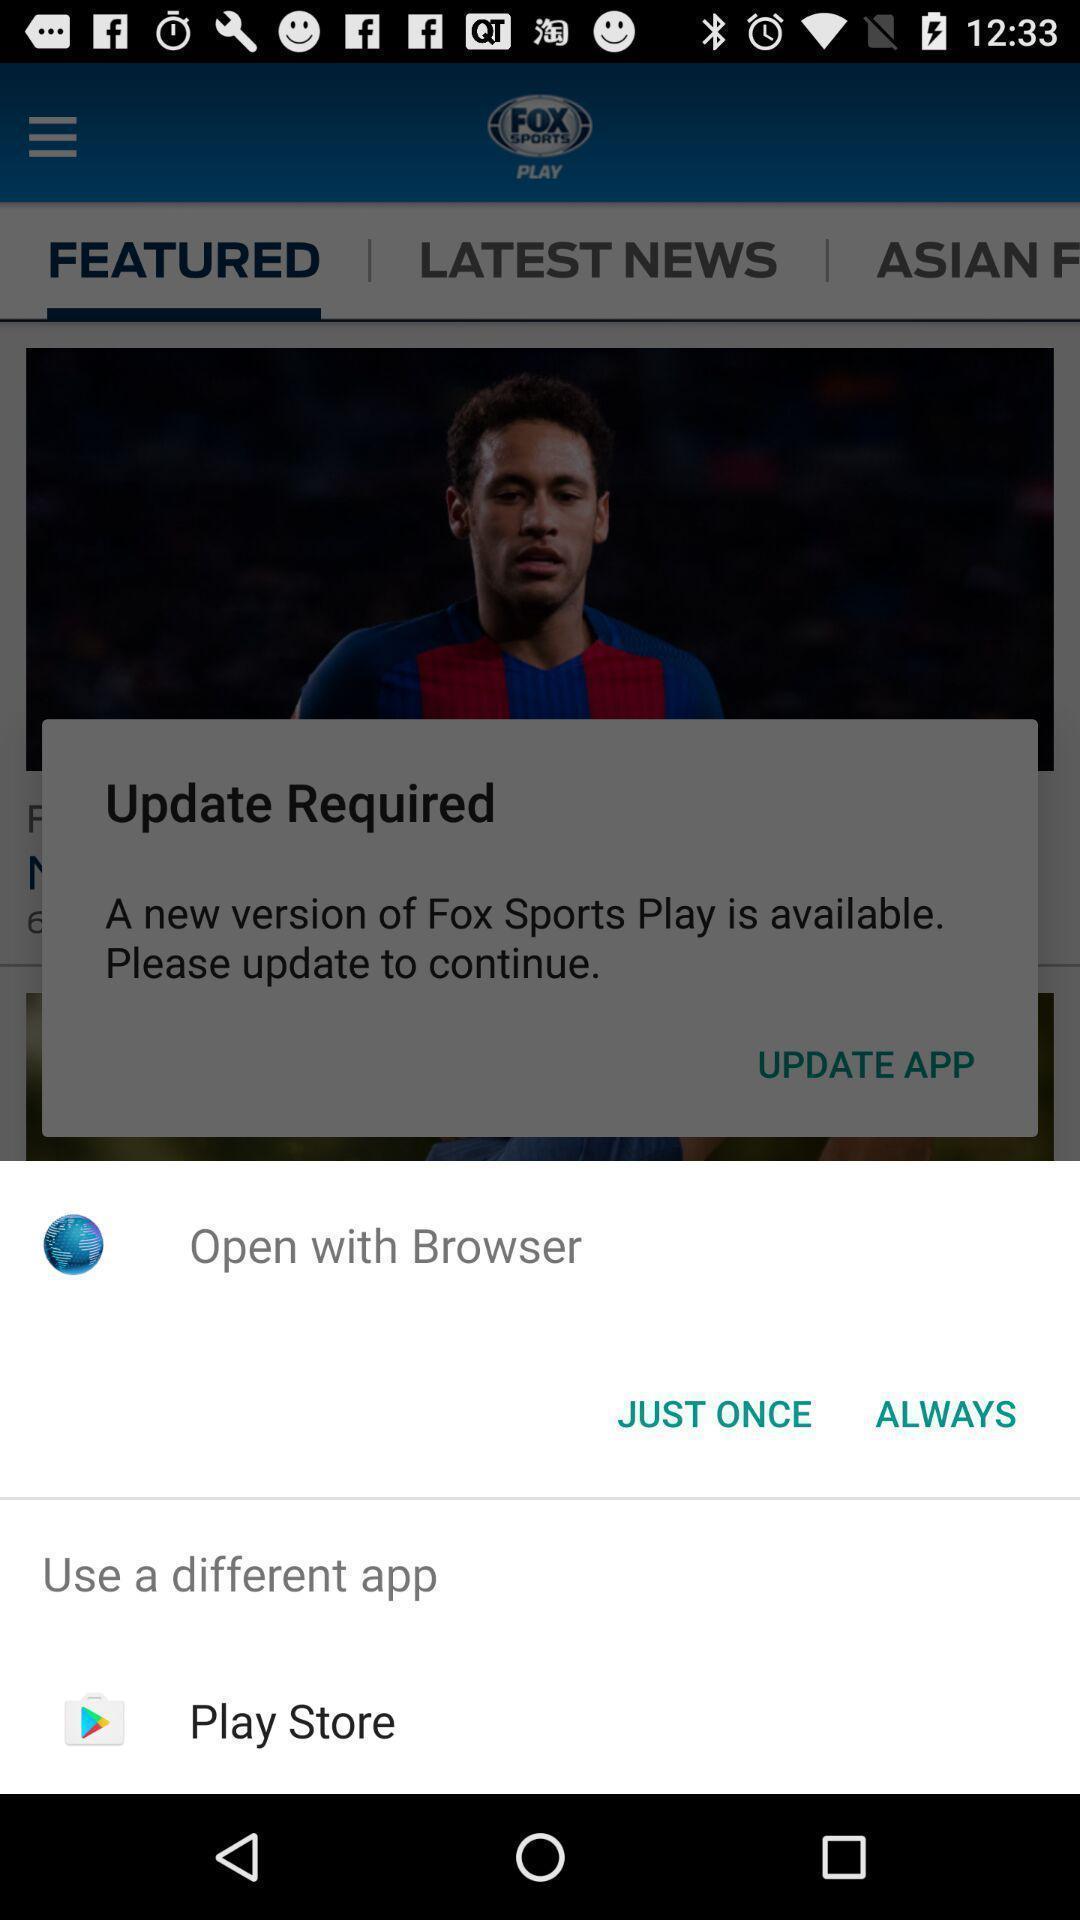Describe this image in words. Pop-up to open an application with multiple options. 